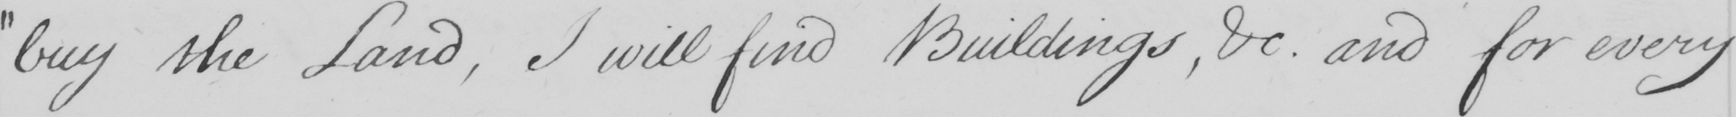Transcribe the text shown in this historical manuscript line. " buy the Land , I will find Buildings , &c . and for every 